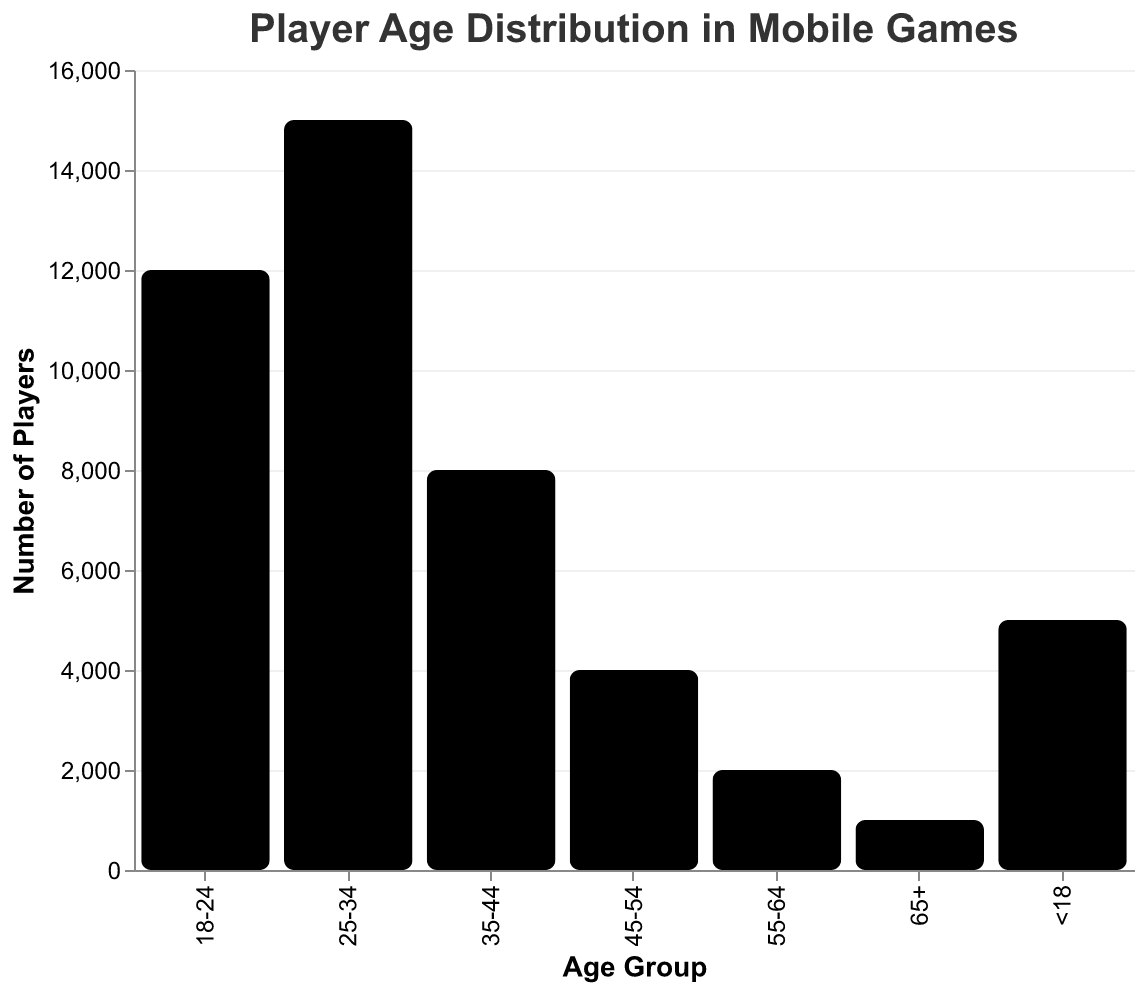What's the title of the figure? The title of the figure is shown at the top and reads "Player Age Distribution in Mobile Games".
Answer: Player Age Distribution in Mobile Games How many age groups are represented in the data? Each unique age category in the x-axis represents an age group. Counting them, we have seven age groups: <18, 18-24, 25-34, 35-44, 45-54, 55-64, 65+.
Answer: 7 Which age group has the highest number of players? By visually comparing the heights of the bars, the 25-34 age group has the highest bar, indicating the highest number of players.
Answer: 25-34 What's the difference in the number of players between the 25-34 and 35-44 age groups? The 25-34 age group has 15,000 players, and the 35-44 age group has 8,000 players. The difference is 15,000 - 8,000 = 7,000 players.
Answer: 7,000 Which age groups have fewer than 5,000 players? The bars corresponding to <18, 45-54, 55-64, and 65+ age groups are below the 5,000 mark on the y-axis. The respective numbers are 5,000, 4,000, 2,000, and 1,000, with <18 needing further examination.
Answer: 45-54, 55-64, 65+ What is the total number of players across all age groups? Sum the number of players of all age groups: 5,000 + 12,000 + 15,000 + 8,000 + 4,000 + 2,000 + 1,000 = 47,000 players.
Answer: 47,000 What is the percentage of players in the 18-24 age group relative to all players? First, sum the total number of players: 47,000. The 18-24 age group has 12,000 players. The percentage is (12,000 / 47,000) * 100 ≈ 25.53%.
Answer: ~25.53% Which age group forms approximately one-third of the total player base? Calculate one-third of the total players: (47,000 / 3) ≈ 15,666.67. The 25-34 age group, having 15,000 players, approximately matches this number.
Answer: 25-34 What's the ratio of players in the <18 age group to the 65+ age group? The <18 age group has 5,000 players and the 65+ age group has 1,000 players. The ratio is 5,000:1,000, which simplifies to 5:1.
Answer: 5:1 